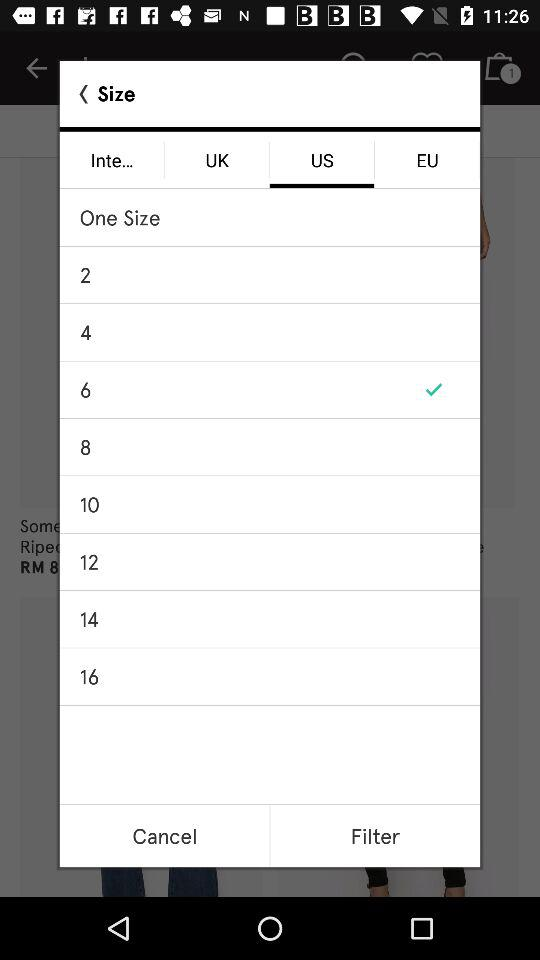Which option is selected? The selected options are "US" and "6". 